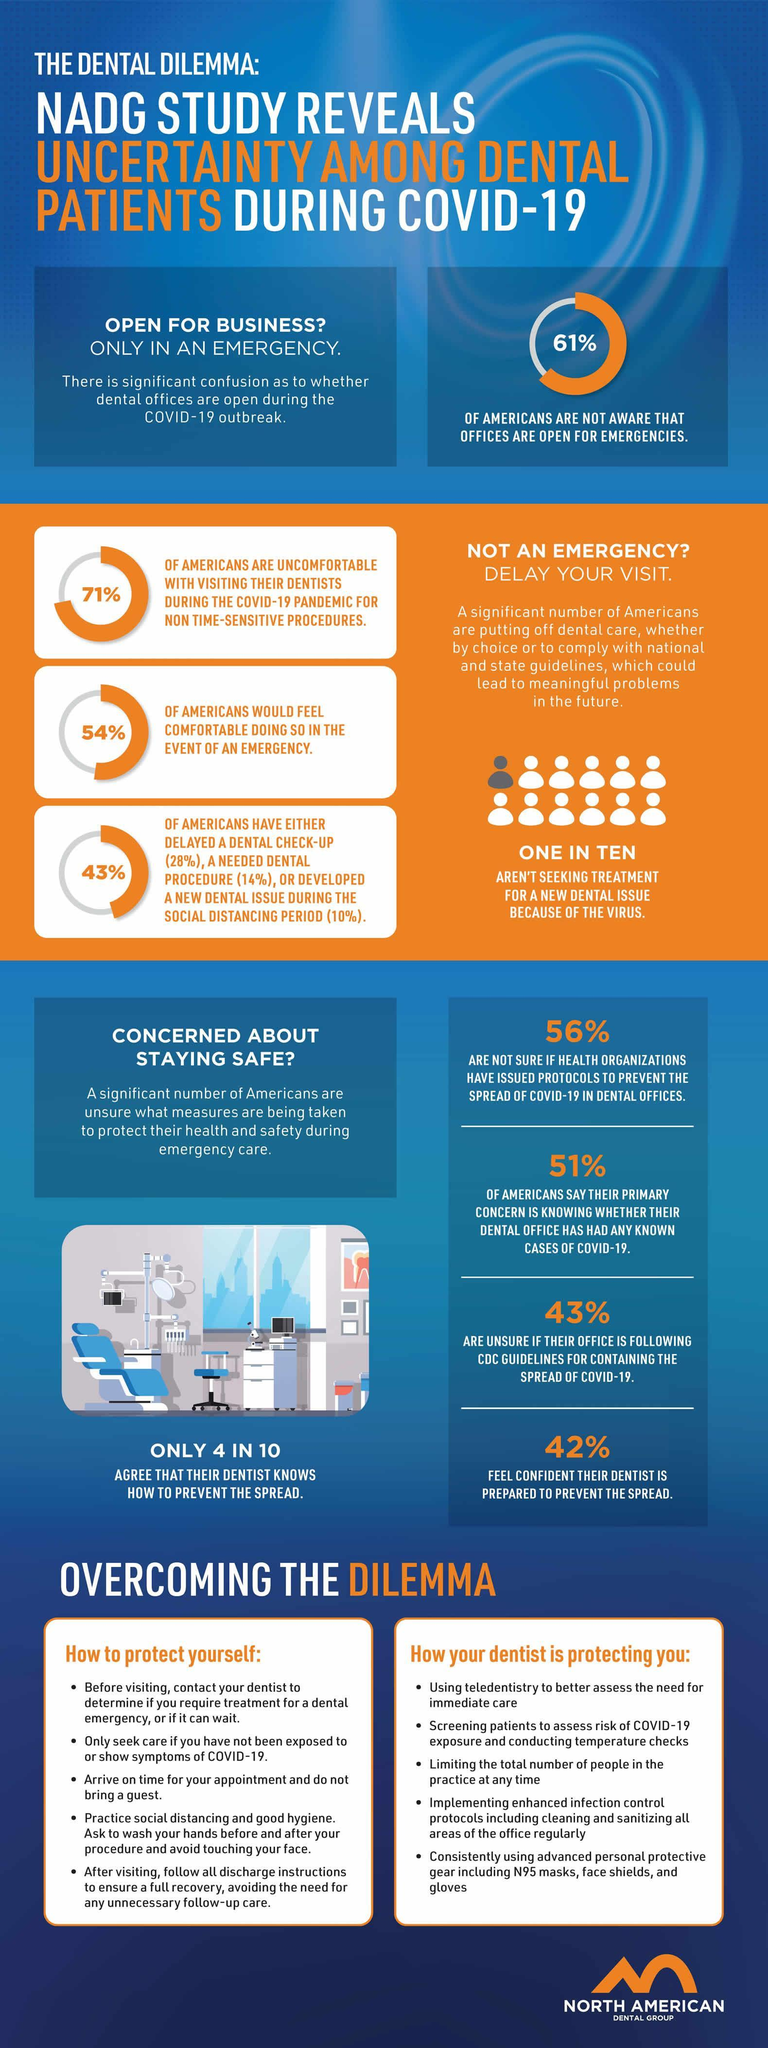What percent of Americans do not feel confident that their dentist is prepared to prevent the COVID-19 spread?
Answer the question with a short phrase. 58% What percentage of Americans are aware that the dental offices are open for emergencies during COVID-19? 39% What percent of Americans are sure that their dental office is following CDC guidelines for containing the spread of COVID-19? 57% 